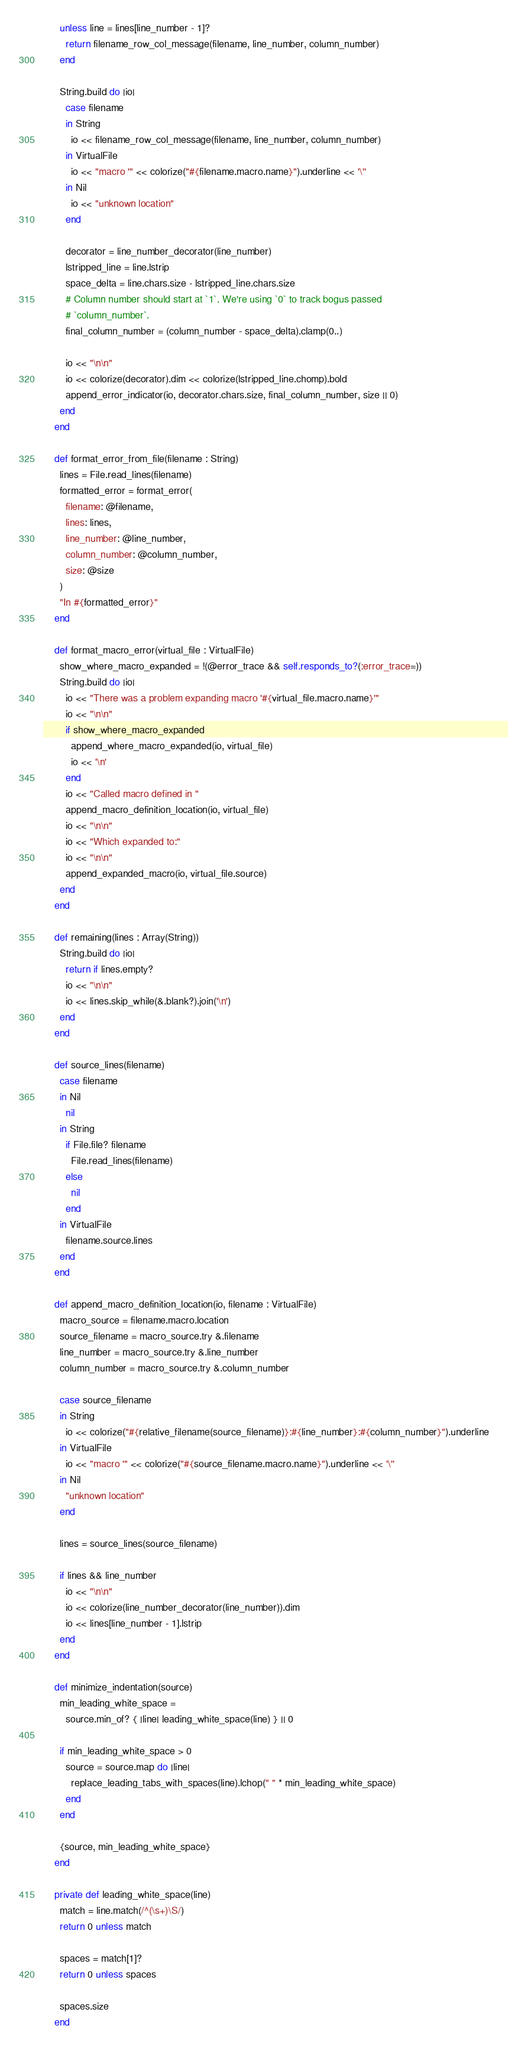<code> <loc_0><loc_0><loc_500><loc_500><_Crystal_>
      unless line = lines[line_number - 1]?
        return filename_row_col_message(filename, line_number, column_number)
      end

      String.build do |io|
        case filename
        in String
          io << filename_row_col_message(filename, line_number, column_number)
        in VirtualFile
          io << "macro '" << colorize("#{filename.macro.name}").underline << '\''
        in Nil
          io << "unknown location"
        end

        decorator = line_number_decorator(line_number)
        lstripped_line = line.lstrip
        space_delta = line.chars.size - lstripped_line.chars.size
        # Column number should start at `1`. We're using `0` to track bogus passed
        # `column_number`.
        final_column_number = (column_number - space_delta).clamp(0..)

        io << "\n\n"
        io << colorize(decorator).dim << colorize(lstripped_line.chomp).bold
        append_error_indicator(io, decorator.chars.size, final_column_number, size || 0)
      end
    end

    def format_error_from_file(filename : String)
      lines = File.read_lines(filename)
      formatted_error = format_error(
        filename: @filename,
        lines: lines,
        line_number: @line_number,
        column_number: @column_number,
        size: @size
      )
      "In #{formatted_error}"
    end

    def format_macro_error(virtual_file : VirtualFile)
      show_where_macro_expanded = !(@error_trace && self.responds_to?(:error_trace=))
      String.build do |io|
        io << "There was a problem expanding macro '#{virtual_file.macro.name}'"
        io << "\n\n"
        if show_where_macro_expanded
          append_where_macro_expanded(io, virtual_file)
          io << '\n'
        end
        io << "Called macro defined in "
        append_macro_definition_location(io, virtual_file)
        io << "\n\n"
        io << "Which expanded to:"
        io << "\n\n"
        append_expanded_macro(io, virtual_file.source)
      end
    end

    def remaining(lines : Array(String))
      String.build do |io|
        return if lines.empty?
        io << "\n\n"
        io << lines.skip_while(&.blank?).join('\n')
      end
    end

    def source_lines(filename)
      case filename
      in Nil
        nil
      in String
        if File.file? filename
          File.read_lines(filename)
        else
          nil
        end
      in VirtualFile
        filename.source.lines
      end
    end

    def append_macro_definition_location(io, filename : VirtualFile)
      macro_source = filename.macro.location
      source_filename = macro_source.try &.filename
      line_number = macro_source.try &.line_number
      column_number = macro_source.try &.column_number

      case source_filename
      in String
        io << colorize("#{relative_filename(source_filename)}:#{line_number}:#{column_number}").underline
      in VirtualFile
        io << "macro '" << colorize("#{source_filename.macro.name}").underline << '\''
      in Nil
        "unknown location"
      end

      lines = source_lines(source_filename)

      if lines && line_number
        io << "\n\n"
        io << colorize(line_number_decorator(line_number)).dim
        io << lines[line_number - 1].lstrip
      end
    end

    def minimize_indentation(source)
      min_leading_white_space =
        source.min_of? { |line| leading_white_space(line) } || 0

      if min_leading_white_space > 0
        source = source.map do |line|
          replace_leading_tabs_with_spaces(line).lchop(" " * min_leading_white_space)
        end
      end

      {source, min_leading_white_space}
    end

    private def leading_white_space(line)
      match = line.match(/^(\s+)\S/)
      return 0 unless match

      spaces = match[1]?
      return 0 unless spaces

      spaces.size
    end
</code> 